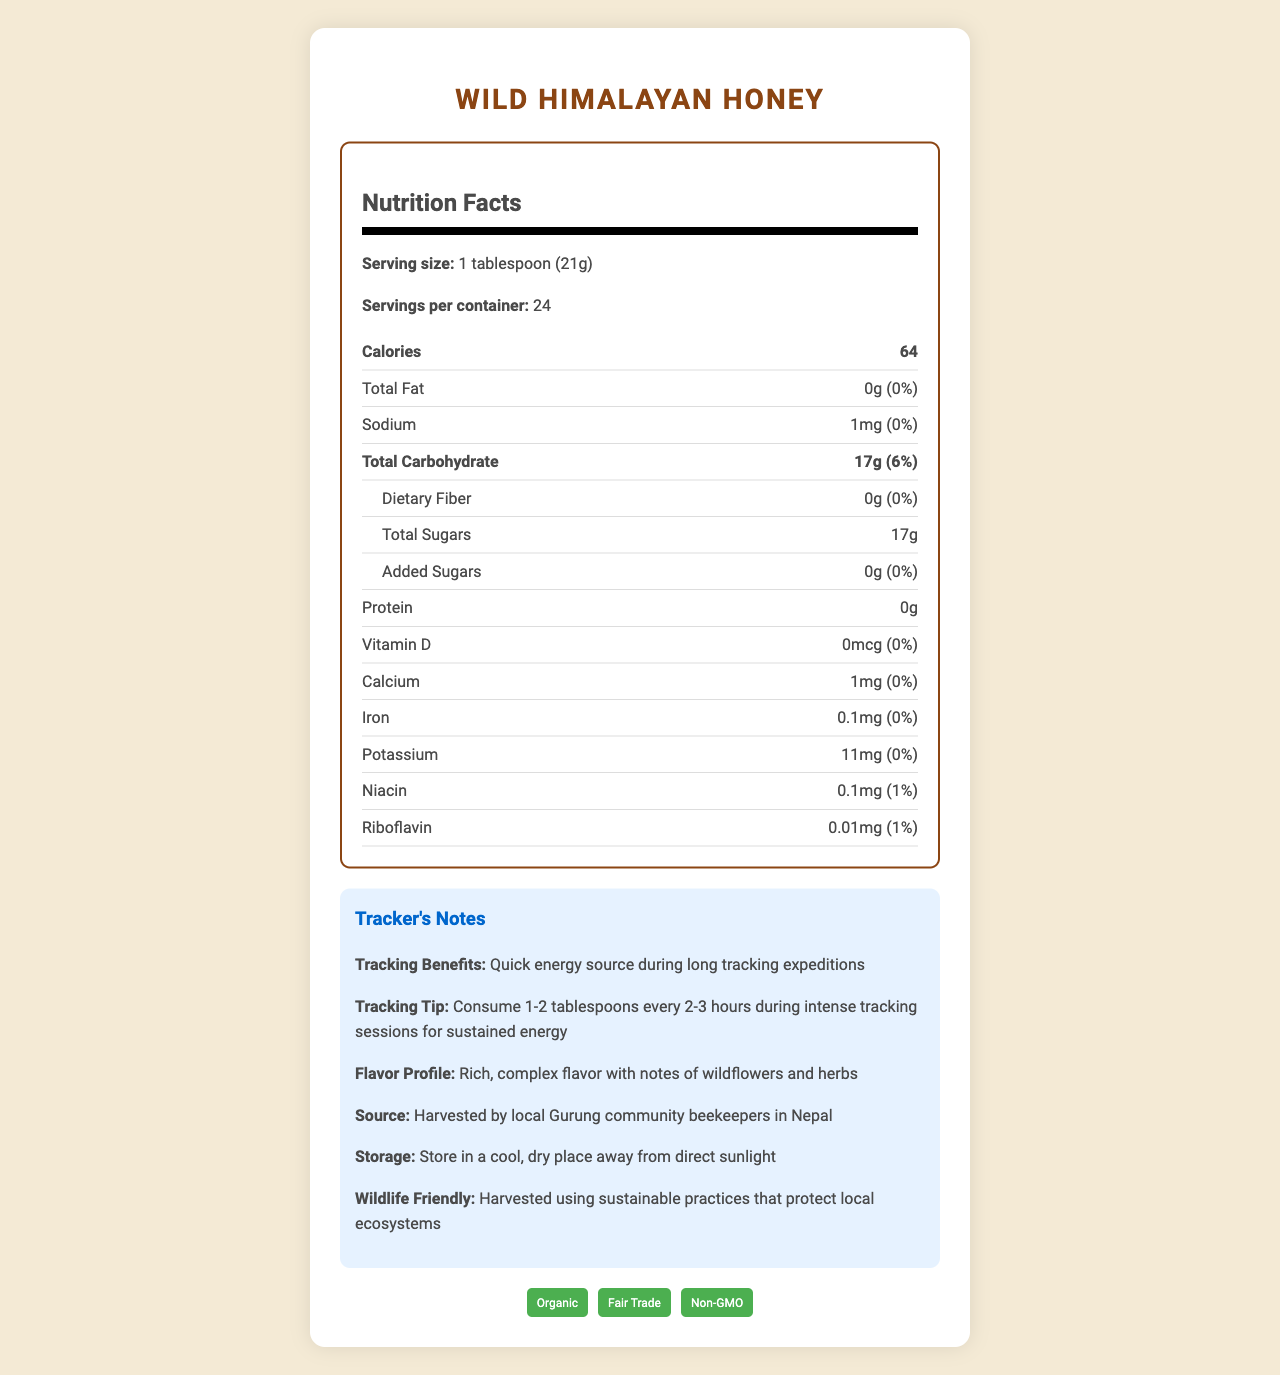what is the serving size? The serving size is specified as "1 tablespoon (21g)" in the Nutrition Facts section.
Answer: 1 tablespoon (21g) how many calories are in one serving? The document lists the calories per serving as 64.
Answer: 64 how much sodium is in one serving? The sodium content per serving is provided as 1mg.
Answer: 1mg is there any protein in this product? The protein content is listed as 0g, indicating that there is no protein in the product.
Answer: No how should Wild Himalayan Honey be stored? The storage instructions specify to keep the honey in a cool, dry place away from direct sunlight.
Answer: Store in a cool, dry place away from direct sunlight how often should you consume this honey during tracking sessions? The tracking tip suggests consuming 1-2 tablespoons every 2-3 hours for sustained energy during intense tracking sessions.
Answer: Consume 1-2 tablespoons every 2-3 hours what community is responsible for harvesting this honey? The document states that the honey is harvested by the local Gurung community beekeepers in Nepal.
Answer: The local Gurung community beekeepers in Nepal which of the following is <b>not</b> a certification mentioned for Wild Himalayan Honey? A. Organic B. Fair Trade C. Gluten-Free The certifications listed are "Organic," "Fair Trade," and "Non-GMO." "Gluten-Free" is not mentioned.
Answer: C. Gluten-Free how much iron does this honey contain per serving? A. 0.1mg B. 0.5mg C. 1mg D. 5mg The iron content per serving is 0.1mg, as mentioned in the Nutrition Facts section.
Answer: A. 0.1mg is the fat content per serving high? The fat content per serving is 0g, which is 0% of the daily value, indicating it is not high.
Answer: No does this honey contain any added sugars? The document specifies that the amount of added sugars is 0g.
Answer: No describe the main idea of the document. The document outlines the nutritional content, tracking benefits, flavor, source, and storage of Wild Himalayan Honey. It also emphasizes that the honey is organically sourced, fair-trade certified, and harvested sustainably.
Answer: The document provides detailed nutrition information for Wild Himalayan Honey, highlighting its benefits, particularly for wildlife trackers, its source, flavor profile, and storage instructions. Additionally, it emphasizes its certifications and sustainable harvesting practices. is Wild Himalayan Honey gluten-free? The document does not provide any information about whether the honey is gluten-free.
Answer: Cannot be determined how much niacin does this honey provide per serving? The niacin content per serving is listed as 0.1mg in the additional nutrients section.
Answer: 0.1mg 